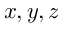Convert formula to latex. <formula><loc_0><loc_0><loc_500><loc_500>x , y , z</formula> 